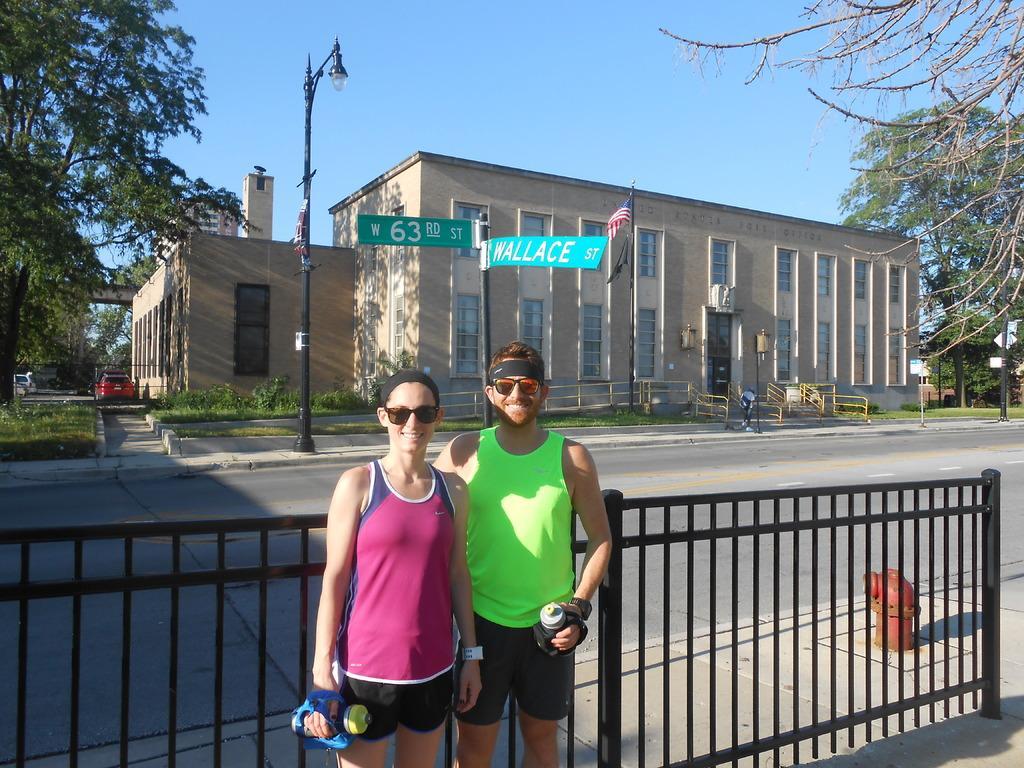Please provide a concise description of this image. In the foreground of this image, there is a man and a woman standing in front of a railing. Behind them, there is a road, few poles, boards, trees, vehicles, building and the sky. 